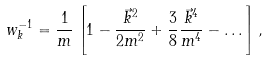<formula> <loc_0><loc_0><loc_500><loc_500>w _ { k } ^ { - 1 } = \frac { 1 } { m } \left [ 1 - \frac { \vec { k } ^ { 2 } } { 2 m ^ { 2 } } + \frac { 3 } { 8 } \frac { \vec { k } ^ { 4 } } { m ^ { 4 } } - \dots \right ] ,</formula> 